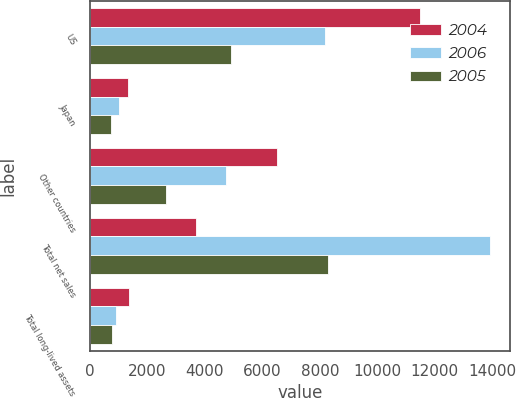Convert chart to OTSL. <chart><loc_0><loc_0><loc_500><loc_500><stacked_bar_chart><ecel><fcel>US<fcel>Japan<fcel>Other countries<fcel>Total net sales<fcel>Total long-lived assets<nl><fcel>2004<fcel>11486<fcel>1327<fcel>6502<fcel>3682<fcel>1368<nl><fcel>2006<fcel>8194<fcel>1021<fcel>4716<fcel>13931<fcel>913<nl><fcel>2005<fcel>4893<fcel>738<fcel>2648<fcel>8279<fcel>761<nl></chart> 